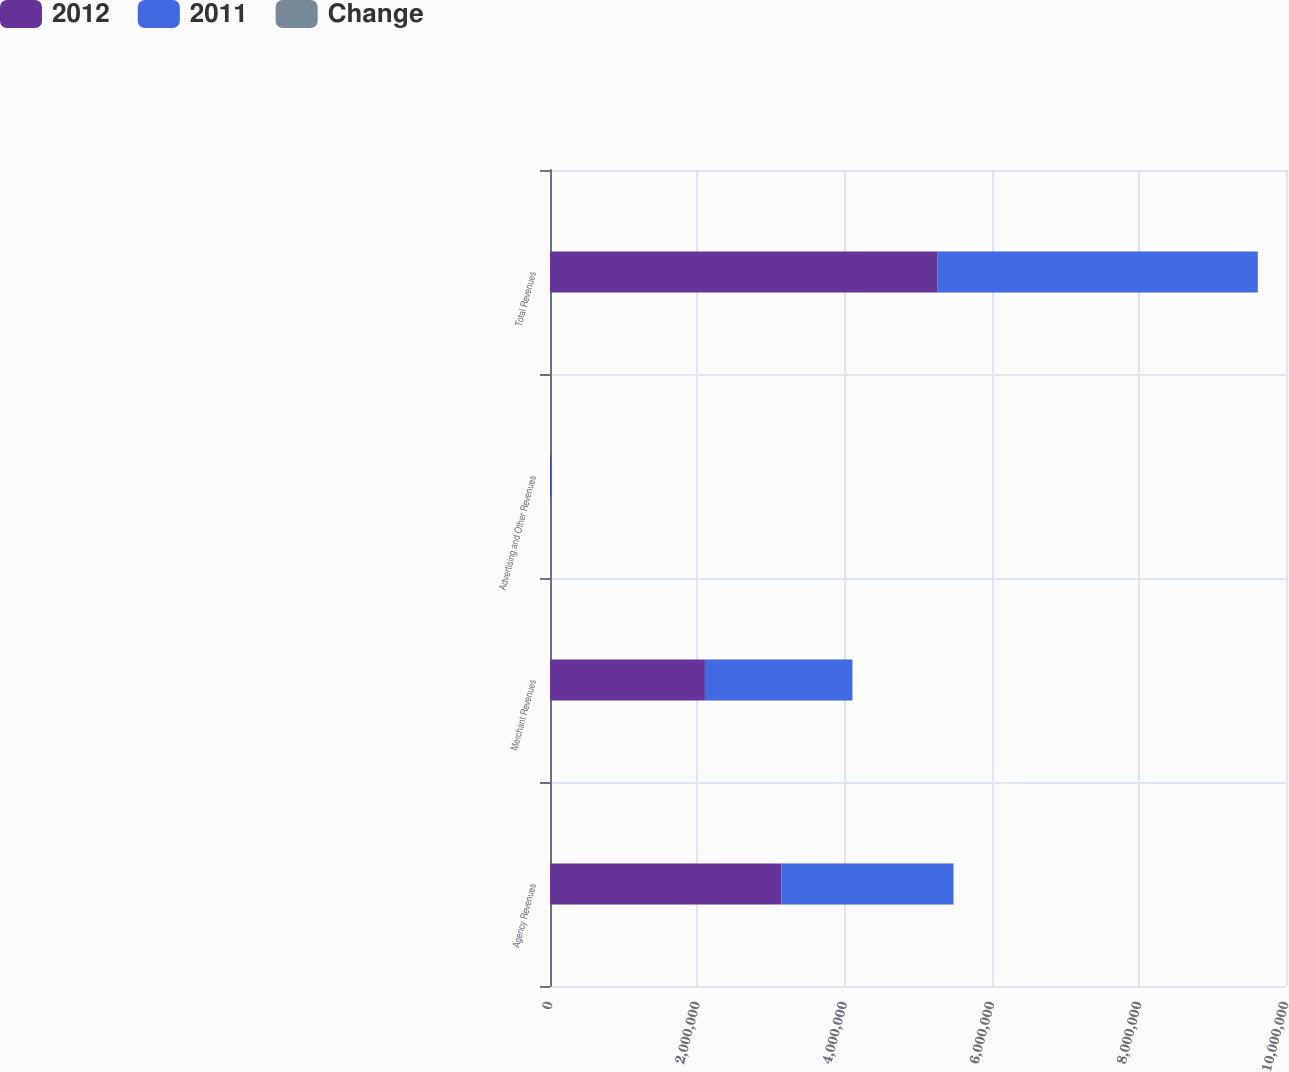Convert chart. <chart><loc_0><loc_0><loc_500><loc_500><stacked_bar_chart><ecel><fcel>Agency Revenues<fcel>Merchant Revenues<fcel>Advertising and Other Revenues<fcel>Total Revenues<nl><fcel>2012<fcel>3.14282e+06<fcel>2.10475e+06<fcel>13389<fcel>5.26096e+06<nl><fcel>2011<fcel>2.33925e+06<fcel>2.00443e+06<fcel>11925<fcel>4.35561e+06<nl><fcel>Change<fcel>34.4<fcel>5<fcel>12.3<fcel>20.8<nl></chart> 